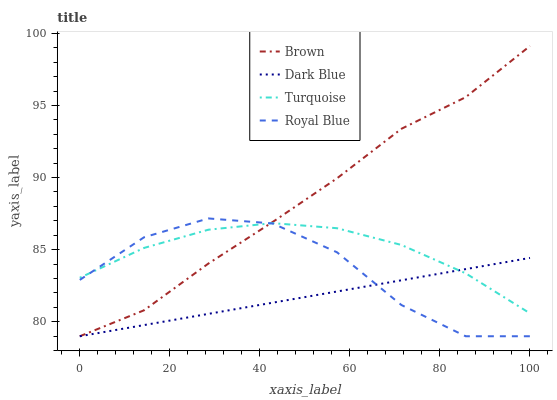Does Dark Blue have the minimum area under the curve?
Answer yes or no. Yes. Does Brown have the maximum area under the curve?
Answer yes or no. Yes. Does Turquoise have the minimum area under the curve?
Answer yes or no. No. Does Turquoise have the maximum area under the curve?
Answer yes or no. No. Is Dark Blue the smoothest?
Answer yes or no. Yes. Is Royal Blue the roughest?
Answer yes or no. Yes. Is Turquoise the smoothest?
Answer yes or no. No. Is Turquoise the roughest?
Answer yes or no. No. Does Turquoise have the lowest value?
Answer yes or no. No. Does Turquoise have the highest value?
Answer yes or no. No. 